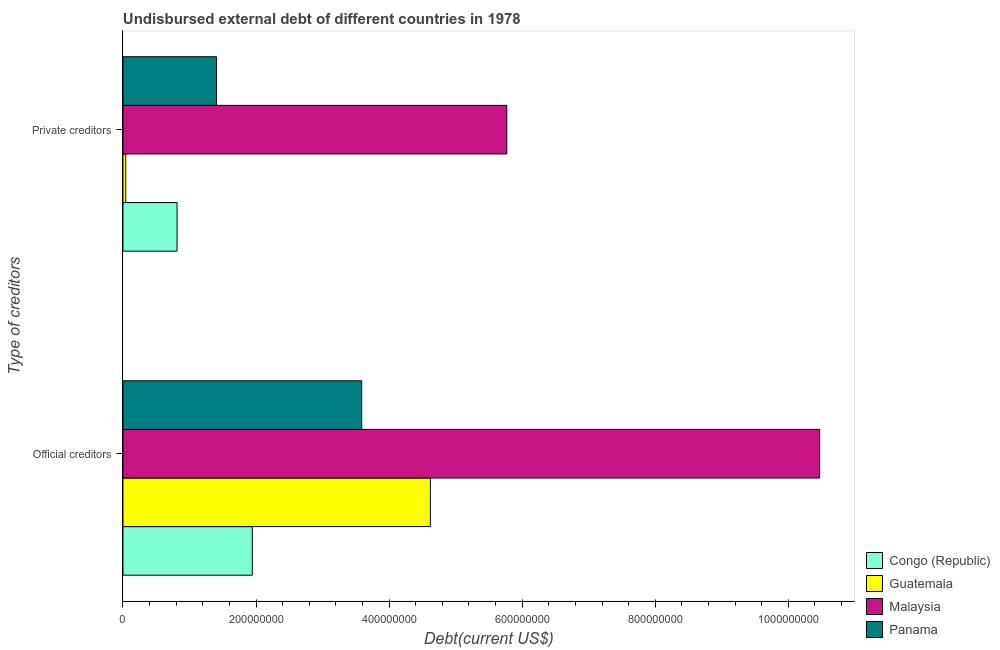How many groups of bars are there?
Provide a short and direct response. 2. Are the number of bars on each tick of the Y-axis equal?
Provide a succinct answer. Yes. What is the label of the 2nd group of bars from the top?
Provide a short and direct response. Official creditors. What is the undisbursed external debt of official creditors in Panama?
Give a very brief answer. 3.59e+08. Across all countries, what is the maximum undisbursed external debt of private creditors?
Provide a short and direct response. 5.77e+08. Across all countries, what is the minimum undisbursed external debt of official creditors?
Provide a succinct answer. 1.94e+08. In which country was the undisbursed external debt of official creditors maximum?
Your answer should be compact. Malaysia. In which country was the undisbursed external debt of official creditors minimum?
Offer a very short reply. Congo (Republic). What is the total undisbursed external debt of private creditors in the graph?
Keep it short and to the point. 8.03e+08. What is the difference between the undisbursed external debt of private creditors in Congo (Republic) and that in Malaysia?
Your answer should be very brief. -4.96e+08. What is the difference between the undisbursed external debt of private creditors in Guatemala and the undisbursed external debt of official creditors in Malaysia?
Offer a very short reply. -1.04e+09. What is the average undisbursed external debt of official creditors per country?
Keep it short and to the point. 5.16e+08. What is the difference between the undisbursed external debt of private creditors and undisbursed external debt of official creditors in Guatemala?
Provide a succinct answer. -4.58e+08. In how many countries, is the undisbursed external debt of official creditors greater than 840000000 US$?
Keep it short and to the point. 1. What is the ratio of the undisbursed external debt of official creditors in Panama to that in Congo (Republic)?
Keep it short and to the point. 1.85. Is the undisbursed external debt of official creditors in Congo (Republic) less than that in Guatemala?
Your answer should be very brief. Yes. In how many countries, is the undisbursed external debt of private creditors greater than the average undisbursed external debt of private creditors taken over all countries?
Keep it short and to the point. 1. What does the 2nd bar from the top in Private creditors represents?
Your answer should be compact. Malaysia. What does the 3rd bar from the bottom in Official creditors represents?
Your response must be concise. Malaysia. How many bars are there?
Your answer should be compact. 8. Are the values on the major ticks of X-axis written in scientific E-notation?
Offer a very short reply. No. What is the title of the graph?
Make the answer very short. Undisbursed external debt of different countries in 1978. Does "Mali" appear as one of the legend labels in the graph?
Make the answer very short. No. What is the label or title of the X-axis?
Ensure brevity in your answer.  Debt(current US$). What is the label or title of the Y-axis?
Your response must be concise. Type of creditors. What is the Debt(current US$) in Congo (Republic) in Official creditors?
Provide a succinct answer. 1.94e+08. What is the Debt(current US$) in Guatemala in Official creditors?
Your answer should be compact. 4.62e+08. What is the Debt(current US$) of Malaysia in Official creditors?
Give a very brief answer. 1.05e+09. What is the Debt(current US$) of Panama in Official creditors?
Your response must be concise. 3.59e+08. What is the Debt(current US$) in Congo (Republic) in Private creditors?
Make the answer very short. 8.13e+07. What is the Debt(current US$) of Guatemala in Private creditors?
Your answer should be very brief. 4.18e+06. What is the Debt(current US$) of Malaysia in Private creditors?
Provide a short and direct response. 5.77e+08. What is the Debt(current US$) of Panama in Private creditors?
Provide a short and direct response. 1.41e+08. Across all Type of creditors, what is the maximum Debt(current US$) of Congo (Republic)?
Ensure brevity in your answer.  1.94e+08. Across all Type of creditors, what is the maximum Debt(current US$) in Guatemala?
Keep it short and to the point. 4.62e+08. Across all Type of creditors, what is the maximum Debt(current US$) in Malaysia?
Keep it short and to the point. 1.05e+09. Across all Type of creditors, what is the maximum Debt(current US$) of Panama?
Provide a short and direct response. 3.59e+08. Across all Type of creditors, what is the minimum Debt(current US$) in Congo (Republic)?
Give a very brief answer. 8.13e+07. Across all Type of creditors, what is the minimum Debt(current US$) of Guatemala?
Your answer should be compact. 4.18e+06. Across all Type of creditors, what is the minimum Debt(current US$) of Malaysia?
Your answer should be compact. 5.77e+08. Across all Type of creditors, what is the minimum Debt(current US$) of Panama?
Give a very brief answer. 1.41e+08. What is the total Debt(current US$) in Congo (Republic) in the graph?
Keep it short and to the point. 2.76e+08. What is the total Debt(current US$) of Guatemala in the graph?
Your answer should be very brief. 4.66e+08. What is the total Debt(current US$) in Malaysia in the graph?
Give a very brief answer. 1.62e+09. What is the total Debt(current US$) in Panama in the graph?
Your answer should be very brief. 4.99e+08. What is the difference between the Debt(current US$) of Congo (Republic) in Official creditors and that in Private creditors?
Offer a terse response. 1.13e+08. What is the difference between the Debt(current US$) in Guatemala in Official creditors and that in Private creditors?
Provide a short and direct response. 4.58e+08. What is the difference between the Debt(current US$) in Malaysia in Official creditors and that in Private creditors?
Provide a succinct answer. 4.70e+08. What is the difference between the Debt(current US$) of Panama in Official creditors and that in Private creditors?
Make the answer very short. 2.18e+08. What is the difference between the Debt(current US$) in Congo (Republic) in Official creditors and the Debt(current US$) in Guatemala in Private creditors?
Provide a succinct answer. 1.90e+08. What is the difference between the Debt(current US$) of Congo (Republic) in Official creditors and the Debt(current US$) of Malaysia in Private creditors?
Provide a succinct answer. -3.82e+08. What is the difference between the Debt(current US$) of Congo (Republic) in Official creditors and the Debt(current US$) of Panama in Private creditors?
Your answer should be compact. 5.37e+07. What is the difference between the Debt(current US$) of Guatemala in Official creditors and the Debt(current US$) of Malaysia in Private creditors?
Your answer should be very brief. -1.15e+08. What is the difference between the Debt(current US$) in Guatemala in Official creditors and the Debt(current US$) in Panama in Private creditors?
Make the answer very short. 3.21e+08. What is the difference between the Debt(current US$) of Malaysia in Official creditors and the Debt(current US$) of Panama in Private creditors?
Keep it short and to the point. 9.06e+08. What is the average Debt(current US$) of Congo (Republic) per Type of creditors?
Keep it short and to the point. 1.38e+08. What is the average Debt(current US$) of Guatemala per Type of creditors?
Provide a succinct answer. 2.33e+08. What is the average Debt(current US$) in Malaysia per Type of creditors?
Make the answer very short. 8.12e+08. What is the average Debt(current US$) in Panama per Type of creditors?
Your answer should be compact. 2.50e+08. What is the difference between the Debt(current US$) of Congo (Republic) and Debt(current US$) of Guatemala in Official creditors?
Your response must be concise. -2.68e+08. What is the difference between the Debt(current US$) of Congo (Republic) and Debt(current US$) of Malaysia in Official creditors?
Keep it short and to the point. -8.53e+08. What is the difference between the Debt(current US$) in Congo (Republic) and Debt(current US$) in Panama in Official creditors?
Provide a succinct answer. -1.64e+08. What is the difference between the Debt(current US$) of Guatemala and Debt(current US$) of Malaysia in Official creditors?
Provide a succinct answer. -5.85e+08. What is the difference between the Debt(current US$) of Guatemala and Debt(current US$) of Panama in Official creditors?
Your answer should be compact. 1.03e+08. What is the difference between the Debt(current US$) in Malaysia and Debt(current US$) in Panama in Official creditors?
Give a very brief answer. 6.88e+08. What is the difference between the Debt(current US$) of Congo (Republic) and Debt(current US$) of Guatemala in Private creditors?
Your answer should be compact. 7.71e+07. What is the difference between the Debt(current US$) in Congo (Republic) and Debt(current US$) in Malaysia in Private creditors?
Provide a short and direct response. -4.96e+08. What is the difference between the Debt(current US$) of Congo (Republic) and Debt(current US$) of Panama in Private creditors?
Ensure brevity in your answer.  -5.94e+07. What is the difference between the Debt(current US$) of Guatemala and Debt(current US$) of Malaysia in Private creditors?
Make the answer very short. -5.73e+08. What is the difference between the Debt(current US$) in Guatemala and Debt(current US$) in Panama in Private creditors?
Offer a very short reply. -1.36e+08. What is the difference between the Debt(current US$) of Malaysia and Debt(current US$) of Panama in Private creditors?
Make the answer very short. 4.36e+08. What is the ratio of the Debt(current US$) of Congo (Republic) in Official creditors to that in Private creditors?
Give a very brief answer. 2.39. What is the ratio of the Debt(current US$) of Guatemala in Official creditors to that in Private creditors?
Your answer should be very brief. 110.68. What is the ratio of the Debt(current US$) in Malaysia in Official creditors to that in Private creditors?
Offer a very short reply. 1.82. What is the ratio of the Debt(current US$) in Panama in Official creditors to that in Private creditors?
Ensure brevity in your answer.  2.55. What is the difference between the highest and the second highest Debt(current US$) in Congo (Republic)?
Ensure brevity in your answer.  1.13e+08. What is the difference between the highest and the second highest Debt(current US$) in Guatemala?
Your response must be concise. 4.58e+08. What is the difference between the highest and the second highest Debt(current US$) in Malaysia?
Provide a succinct answer. 4.70e+08. What is the difference between the highest and the second highest Debt(current US$) in Panama?
Provide a succinct answer. 2.18e+08. What is the difference between the highest and the lowest Debt(current US$) in Congo (Republic)?
Ensure brevity in your answer.  1.13e+08. What is the difference between the highest and the lowest Debt(current US$) in Guatemala?
Keep it short and to the point. 4.58e+08. What is the difference between the highest and the lowest Debt(current US$) in Malaysia?
Offer a very short reply. 4.70e+08. What is the difference between the highest and the lowest Debt(current US$) in Panama?
Ensure brevity in your answer.  2.18e+08. 